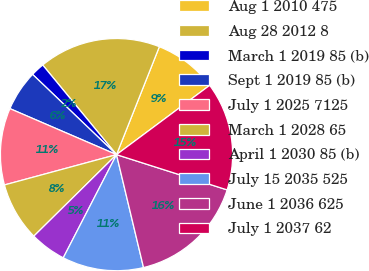<chart> <loc_0><loc_0><loc_500><loc_500><pie_chart><fcel>Aug 1 2010 475<fcel>Aug 28 2012 8<fcel>March 1 2019 85 (b)<fcel>Sept 1 2019 85 (b)<fcel>July 1 2025 7125<fcel>March 1 2028 65<fcel>April 1 2030 85 (b)<fcel>July 15 2035 525<fcel>June 1 2036 625<fcel>July 1 2037 62<nl><fcel>8.81%<fcel>16.98%<fcel>1.89%<fcel>5.66%<fcel>10.69%<fcel>8.18%<fcel>5.03%<fcel>11.32%<fcel>16.35%<fcel>15.09%<nl></chart> 